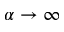Convert formula to latex. <formula><loc_0><loc_0><loc_500><loc_500>\alpha \rightarrow \infty</formula> 